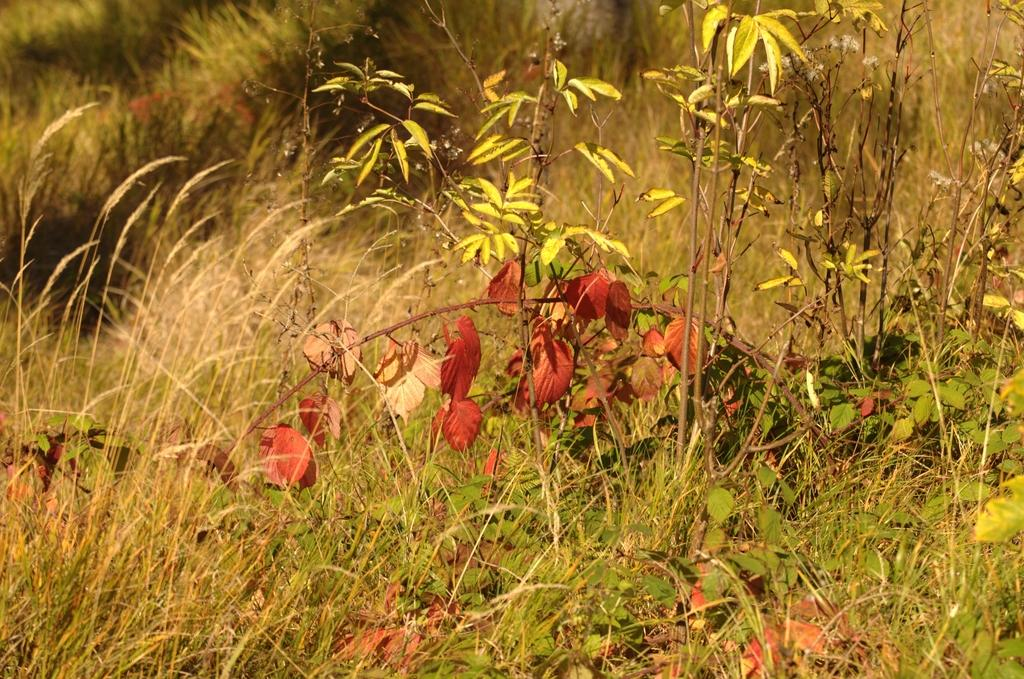What type of vegetation is present in the image? There is grass and small plants in the image. Can you describe the size of the plants in the image? The plants in the image are small. What type of birthday celebration is depicted in the image? There is no birthday celebration present in the image; it only features grass and small plants. Can you tell me where the market is located in the image? There is no market present in the image; it only features grass and small plants. 